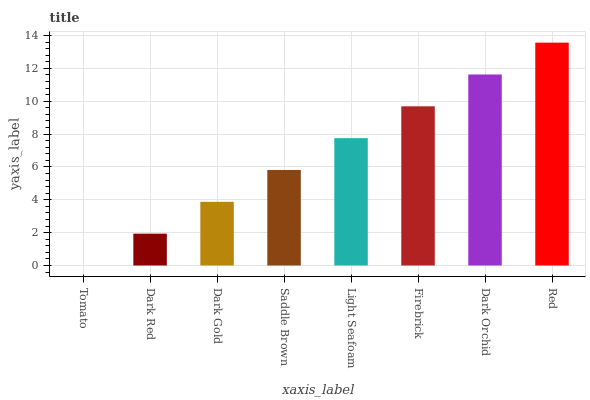Is Tomato the minimum?
Answer yes or no. Yes. Is Red the maximum?
Answer yes or no. Yes. Is Dark Red the minimum?
Answer yes or no. No. Is Dark Red the maximum?
Answer yes or no. No. Is Dark Red greater than Tomato?
Answer yes or no. Yes. Is Tomato less than Dark Red?
Answer yes or no. Yes. Is Tomato greater than Dark Red?
Answer yes or no. No. Is Dark Red less than Tomato?
Answer yes or no. No. Is Light Seafoam the high median?
Answer yes or no. Yes. Is Saddle Brown the low median?
Answer yes or no. Yes. Is Dark Orchid the high median?
Answer yes or no. No. Is Tomato the low median?
Answer yes or no. No. 